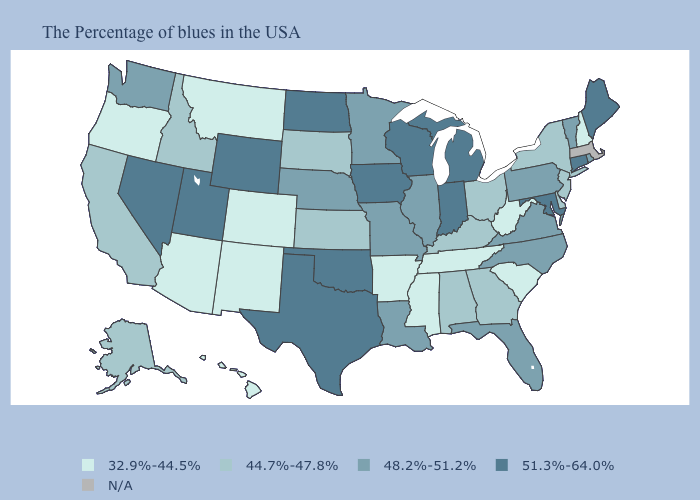Does Nebraska have the highest value in the MidWest?
Short answer required. No. What is the highest value in the USA?
Write a very short answer. 51.3%-64.0%. What is the highest value in the MidWest ?
Answer briefly. 51.3%-64.0%. What is the highest value in the USA?
Give a very brief answer. 51.3%-64.0%. What is the value of Idaho?
Keep it brief. 44.7%-47.8%. Among the states that border Oklahoma , which have the lowest value?
Short answer required. Arkansas, Colorado, New Mexico. Name the states that have a value in the range 48.2%-51.2%?
Give a very brief answer. Rhode Island, Vermont, Pennsylvania, Virginia, North Carolina, Florida, Illinois, Louisiana, Missouri, Minnesota, Nebraska, Washington. What is the value of Arkansas?
Be succinct. 32.9%-44.5%. What is the value of Hawaii?
Concise answer only. 32.9%-44.5%. How many symbols are there in the legend?
Keep it brief. 5. Does the map have missing data?
Answer briefly. Yes. Does the first symbol in the legend represent the smallest category?
Give a very brief answer. Yes. Name the states that have a value in the range N/A?
Quick response, please. Massachusetts. Does New Hampshire have the lowest value in the Northeast?
Write a very short answer. Yes. Does Wyoming have the highest value in the West?
Answer briefly. Yes. 